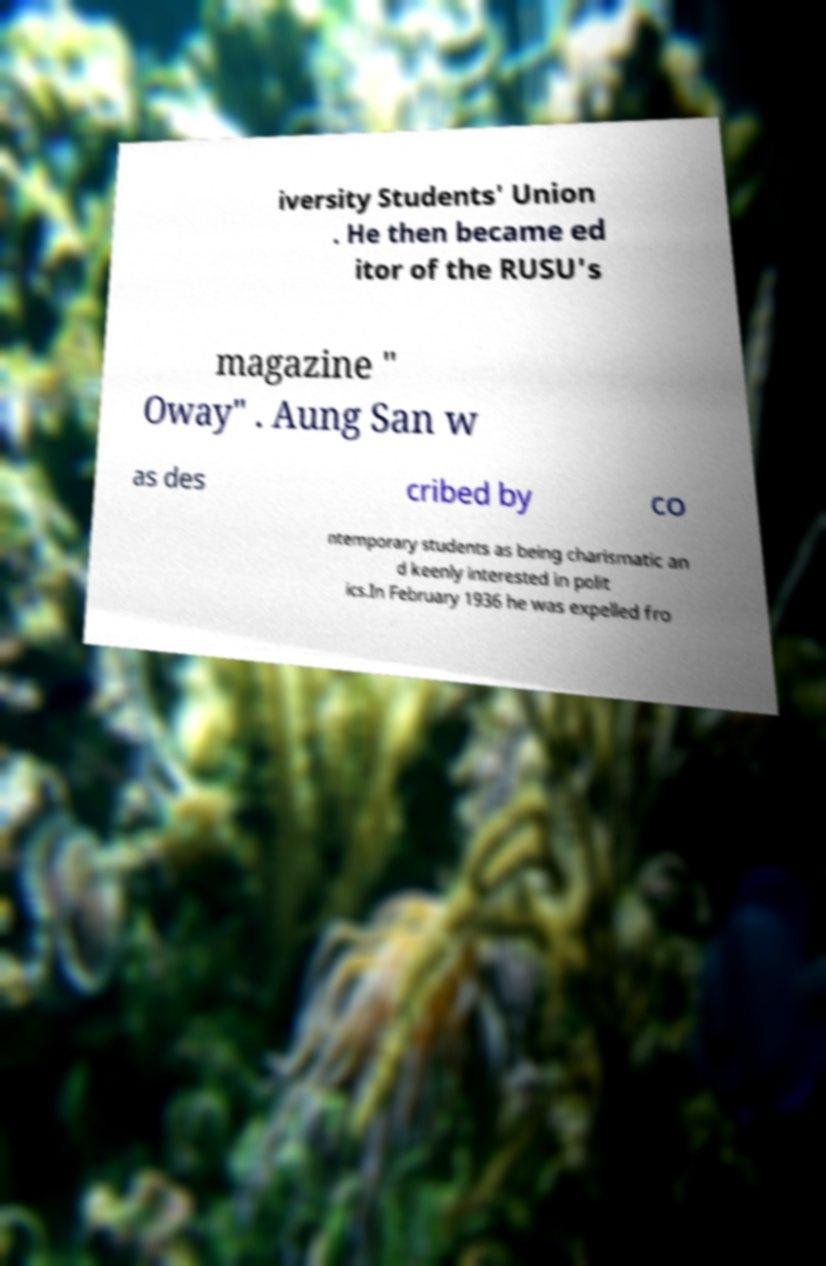Could you assist in decoding the text presented in this image and type it out clearly? iversity Students' Union . He then became ed itor of the RUSU's magazine " Oway" . Aung San w as des cribed by co ntemporary students as being charismatic an d keenly interested in polit ics.In February 1936 he was expelled fro 